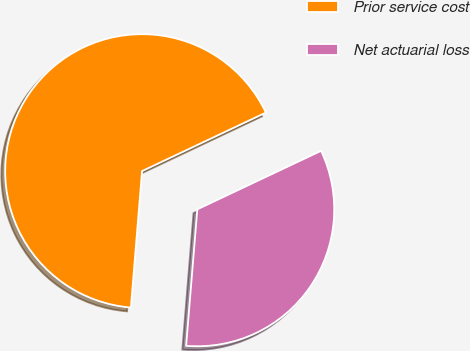Convert chart. <chart><loc_0><loc_0><loc_500><loc_500><pie_chart><fcel>Prior service cost<fcel>Net actuarial loss<nl><fcel>66.67%<fcel>33.33%<nl></chart> 